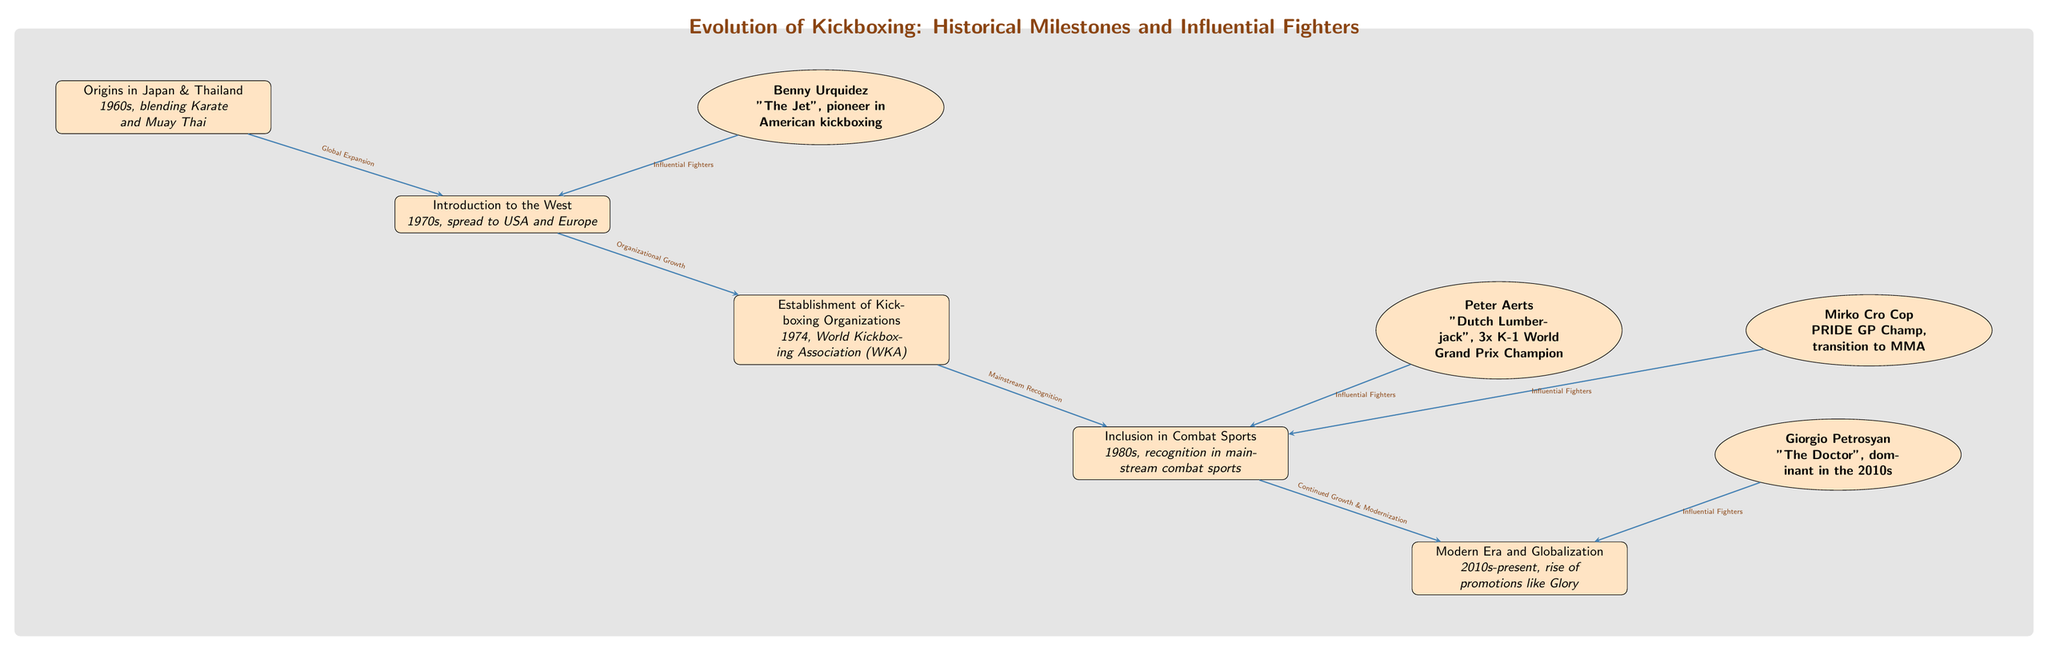What is the first event in the evolution of kickboxing? The first event listed is "Origins in Japan & Thailand" which occurred in the 1960s. This is noted as the beginning point in the historical timeline of kickboxing's evolution.
Answer: Origins in Japan & Thailand Which fighter is known as "The Jet"? The diagram shows that "The Jet" refers to Benny Urquidez, identified as a pioneer in American kickboxing. This nickname is directly associated with the fighter in the diagram.
Answer: Benny Urquidez How many influential fighters are connected to the establishment of kickboxing organizations? The diagram indicates that there are two influential fighters connected to the "Establishment of Kickboxing Organizations". They are Peter Aerts and Mirko Cro Cop, both pointing to the mainstream combat sports recognition.
Answer: 2 What decade saw the introduction of kickboxing to the West? According to the diagram, kickboxing was introduced to the West in the 1970s, as indicated in the event node related to its spread to the USA and Europe.
Answer: 1970s Which event marks the modern era of kickboxing? The "Modern Era and Globalization" event marks the current state of kickboxing evolution, highlighted in the diagram as being from the 2010s to the present.
Answer: Modern Era and Globalization What is the relationship between the event "Inclusion in Combat Sports" and "Modern Era and Globalization"? The diagram shows a flow from "Inclusion in Combat Sports" to "Modern Era and Globalization", indicating that the recognition in mainstream combat sports led to the continued growth and modernization within kickboxing’s evolution.
Answer: Continued Growth & Modernization How many historical milestones are depicted in the diagram? The diagram lists five distinct events as historical milestones in the evolution of kickboxing. This can be counted directly from the event nodes shown.
Answer: 5 What fighter is associated with a transition to MMA? The diagram identifies Mirko Cro Cop as the fighter associated with a transition to MMA, indicating his success beyond kickboxing.
Answer: Mirko Cro Cop What event occurred in 1974 relating to kickboxing? The diagram notes that in 1974, the "World Kickboxing Association (WKA)" was established, marking a significant organizational milestone in kickboxing history.
Answer: Establishment of Kickboxing Organizations 